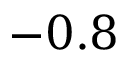<formula> <loc_0><loc_0><loc_500><loc_500>- 0 . 8</formula> 